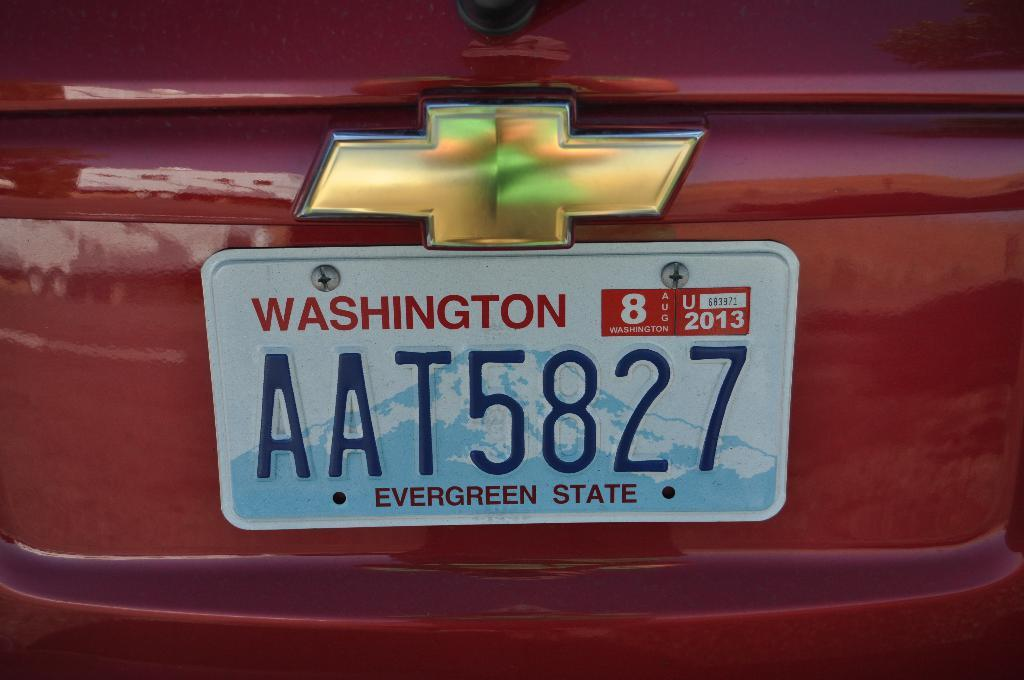<image>
Give a short and clear explanation of the subsequent image. A picture of a Washington state license plate AAT5827. 